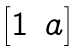<formula> <loc_0><loc_0><loc_500><loc_500>\begin{bmatrix} 1 & a \end{bmatrix}</formula> 